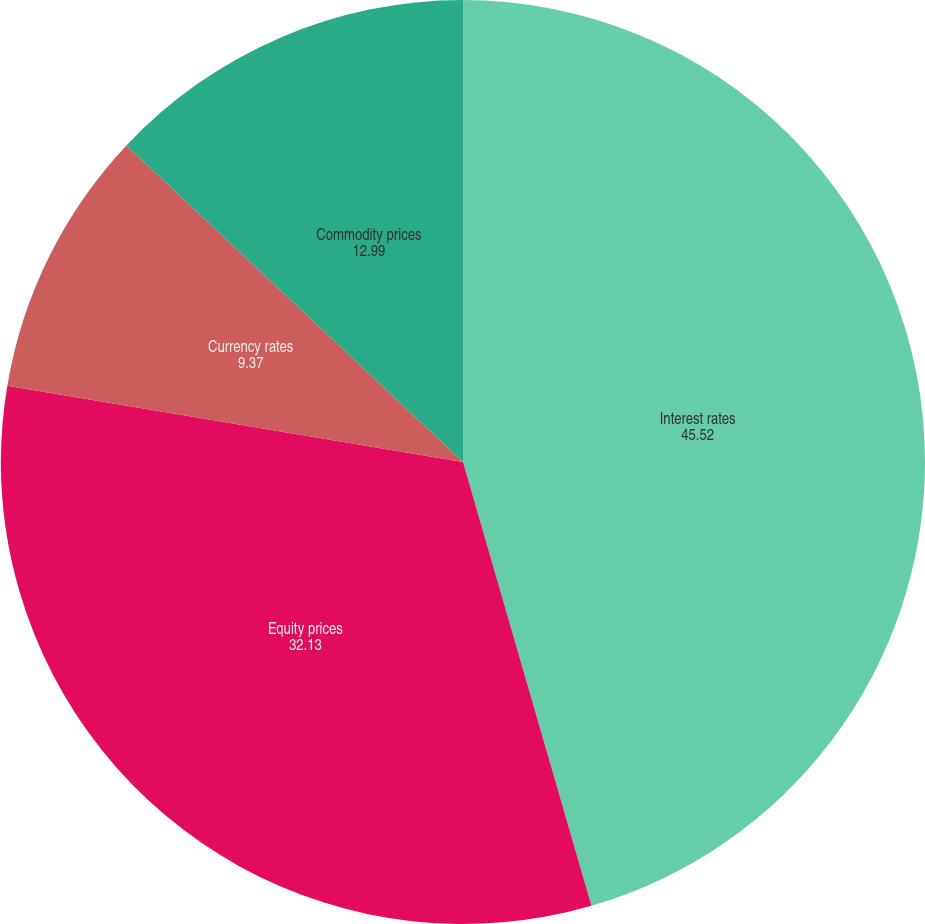Convert chart to OTSL. <chart><loc_0><loc_0><loc_500><loc_500><pie_chart><fcel>Interest rates<fcel>Equity prices<fcel>Currency rates<fcel>Commodity prices<nl><fcel>45.52%<fcel>32.13%<fcel>9.37%<fcel>12.99%<nl></chart> 